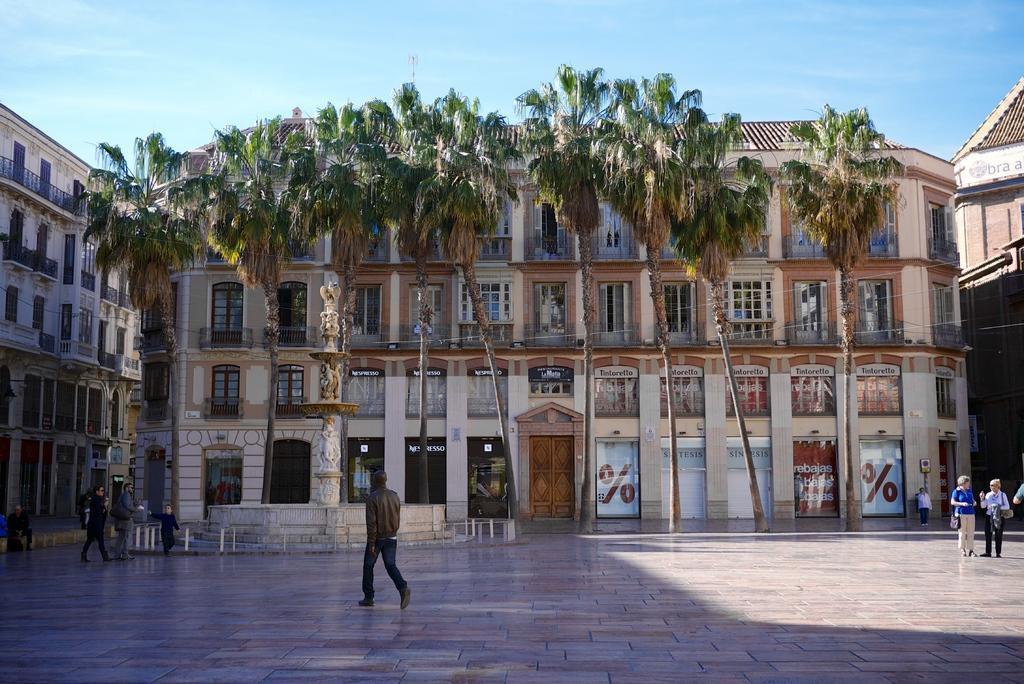Please provide a concise description of this image. In this image we can see some persons walking through the floor in the open area and in the background of the image there are some trees, buildings which has some doors and windows, there is clear sky. 